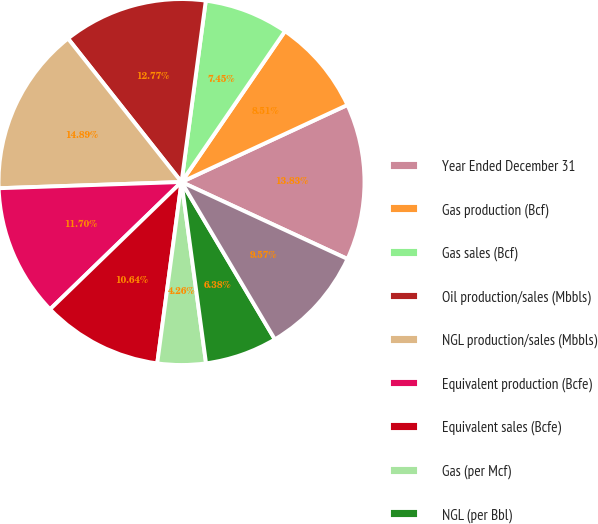<chart> <loc_0><loc_0><loc_500><loc_500><pie_chart><fcel>Year Ended December 31<fcel>Gas production (Bcf)<fcel>Gas sales (Bcf)<fcel>Oil production/sales (Mbbls)<fcel>NGL production/sales (Mbbls)<fcel>Equivalent production (Bcfe)<fcel>Equivalent sales (Bcfe)<fcel>Gas (per Mcf)<fcel>NGL (per Bbl)<fcel>Oil (per Bbl)<nl><fcel>13.83%<fcel>8.51%<fcel>7.45%<fcel>12.77%<fcel>14.89%<fcel>11.7%<fcel>10.64%<fcel>4.26%<fcel>6.38%<fcel>9.57%<nl></chart> 